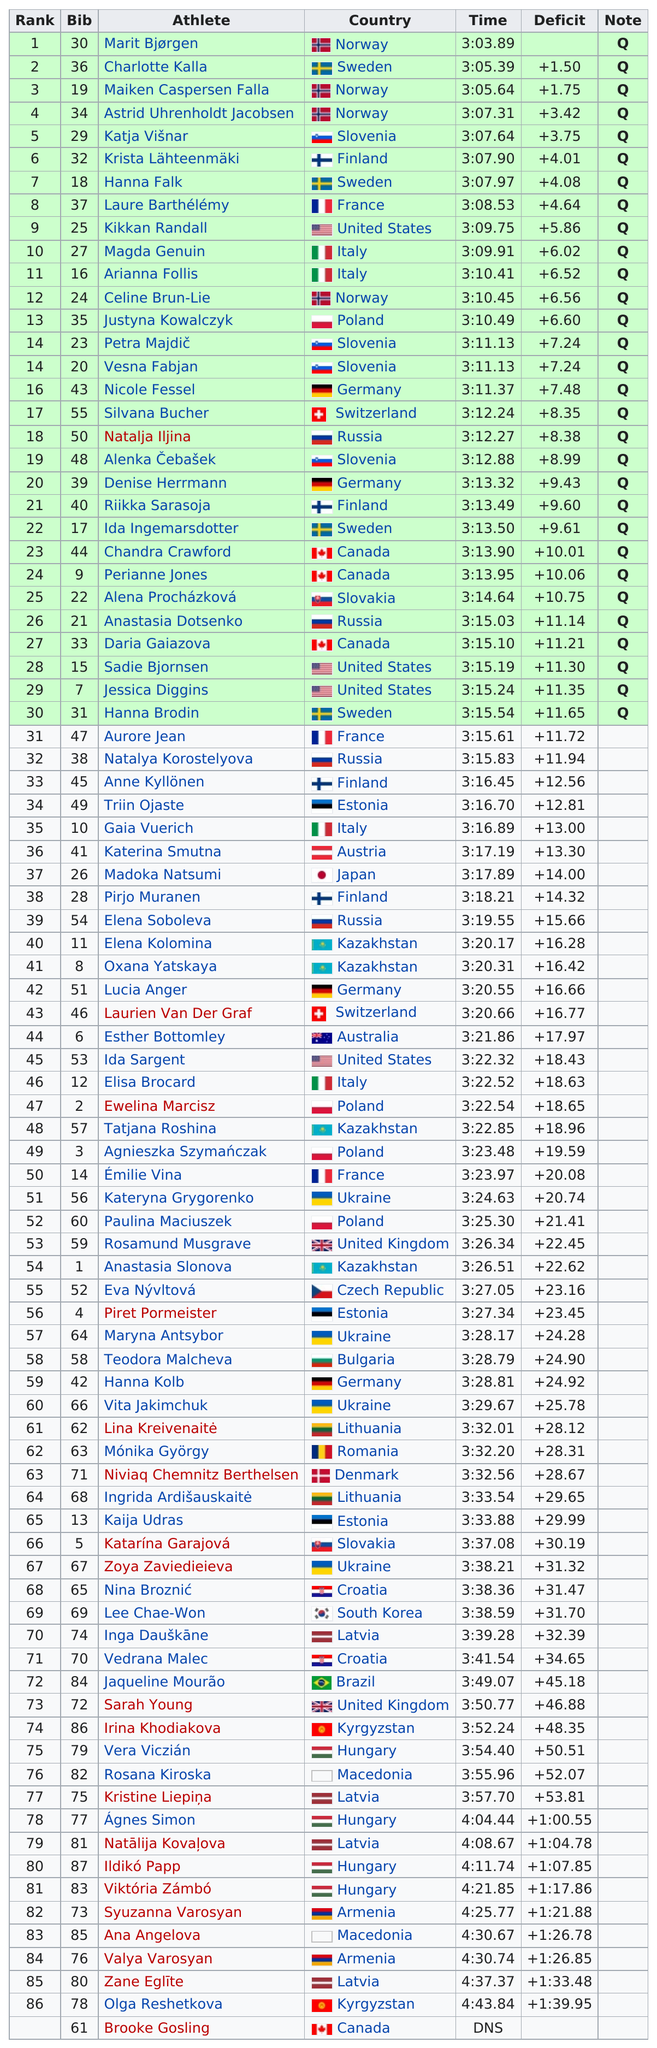Outline some significant characteristics in this image. According to the current ranking, there are 16 teams that are ranked above Silvana Bucher. Marit Bjørgen came in first place. The United States is ranked fourth in the rankings. Olga Reshetkova was the person who was last. Nicole Fessel completed the run in a time of 3 hours and 11 minutes and 37 seconds. 